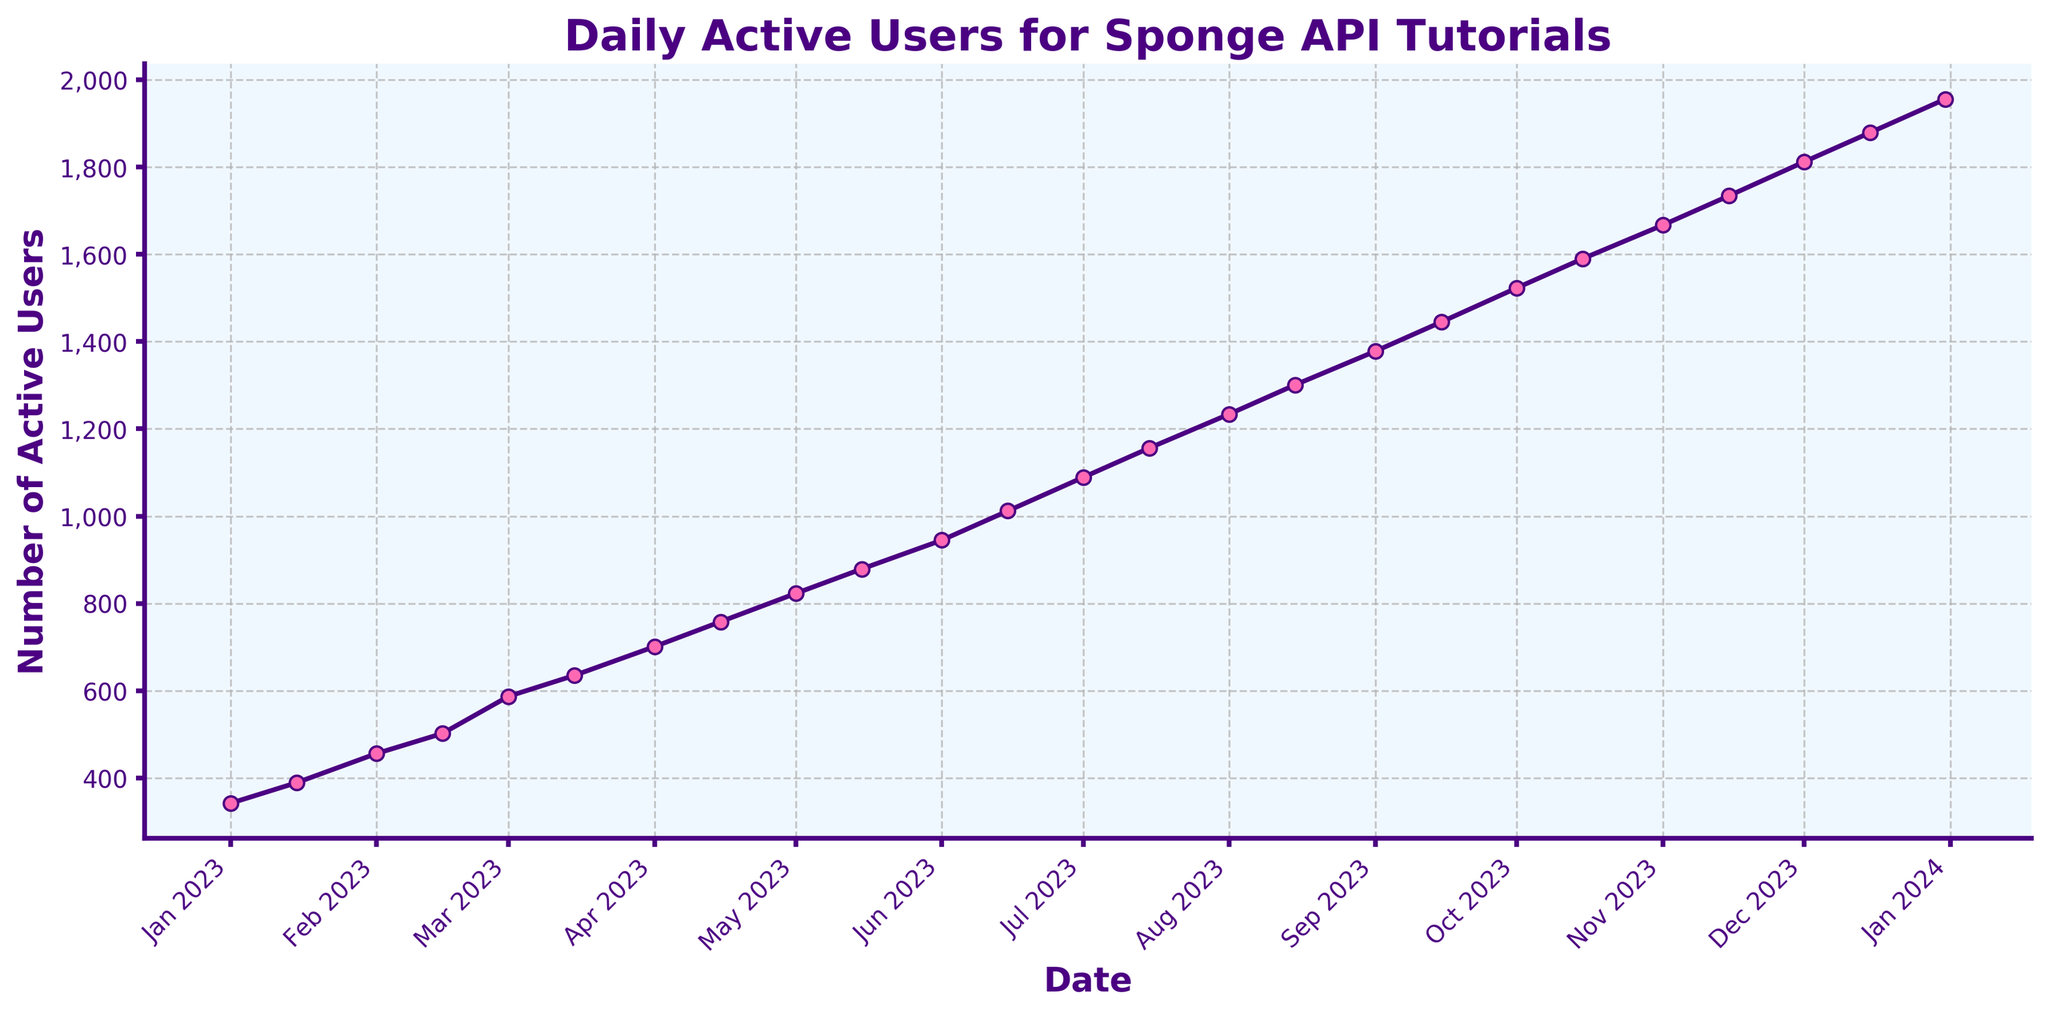What is the trend in daily active users over the year? The trend can be observed by looking at the line's direction from the start to the end of the year. The line shows an upward trend, indicating a steady increase in daily active users throughout the year.
Answer: Increasing Which date had the highest number of daily active users? By looking at the point that is the highest on the vertical axis, it corresponds to December 31, 2023, with the highest number of daily active users.
Answer: December 31, 2023 What is the difference in daily active users between January 1, 2023, and December 31, 2023? Find the daily active users on these two dates and subtract the January value from the December value: 1956 (Dec 31, 2023) - 342 (Jan 1, 2023) = 1614.
Answer: 1614 On average, how many new daily active users were gained each month? Calculate the total increase in users over the year and divide by the number of months. The total increase is 1956 - 342 = 1614. There are 12 months in a year, so 1614 / 12 ≈ 134.5.
Answer: ≈ 134.5 Which month showed the most significant increase in daily active users? Identify the steepest segment of the line. The steepest increase appears between November and December 2023. Comparing the values, the increase from November 15 (1734) to December 15 (1879) is 1879 - 1734 = 145.
Answer: December How many daily active users were there on November 15, 2023? Identify the point corresponding to November 15, 2023. The chart shows that there were 1734 daily active users on this date.
Answer: 1734 What is the average number of daily active users in the first quarter (Jan, Feb, Mar) of 2023? Calculate the total number of daily active users for Jan 1, Jan 15, Feb 1, Feb 15, Mar 1, and Mar 15, then divide by 6: (342 + 389 + 456 + 502 + 587 + 635) / 6 ≈ 485.2.
Answer: ≈ 485.2 How does the number of daily active users on April 1, 2023, compare to October 1, 2023? Compare the two values directly. April 1 has 701 daily active users, and October 1 has 1523 daily active users. Thus, October 1 has significantly more users.
Answer: October 1 Is the increase from August 15, 2023, to August 31, 2023, less than the increase from December 15, 2023, to December 31, 2023? Calculate the differences: August 15 to August 31: 1378 - 1301 = 77. December 15 to December 31: 1956 - 1879 = 77. Both increases are equal.
Answer: Equal What color is used for the markers on the line in the chart? The color of the markers can be observed visually. They are pink.
Answer: Pink 